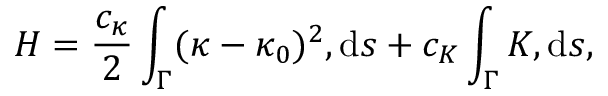Convert formula to latex. <formula><loc_0><loc_0><loc_500><loc_500>H = \frac { c _ { \kappa } } { 2 } \int _ { \Gamma } ( \kappa - \kappa _ { 0 } ) ^ { 2 } , d s + c _ { K } \int _ { \Gamma } K , d s ,</formula> 